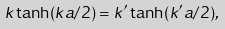Convert formula to latex. <formula><loc_0><loc_0><loc_500><loc_500>k \tanh ( k a / 2 ) = k ^ { \prime } \tanh ( k ^ { \prime } a / 2 ) ,</formula> 